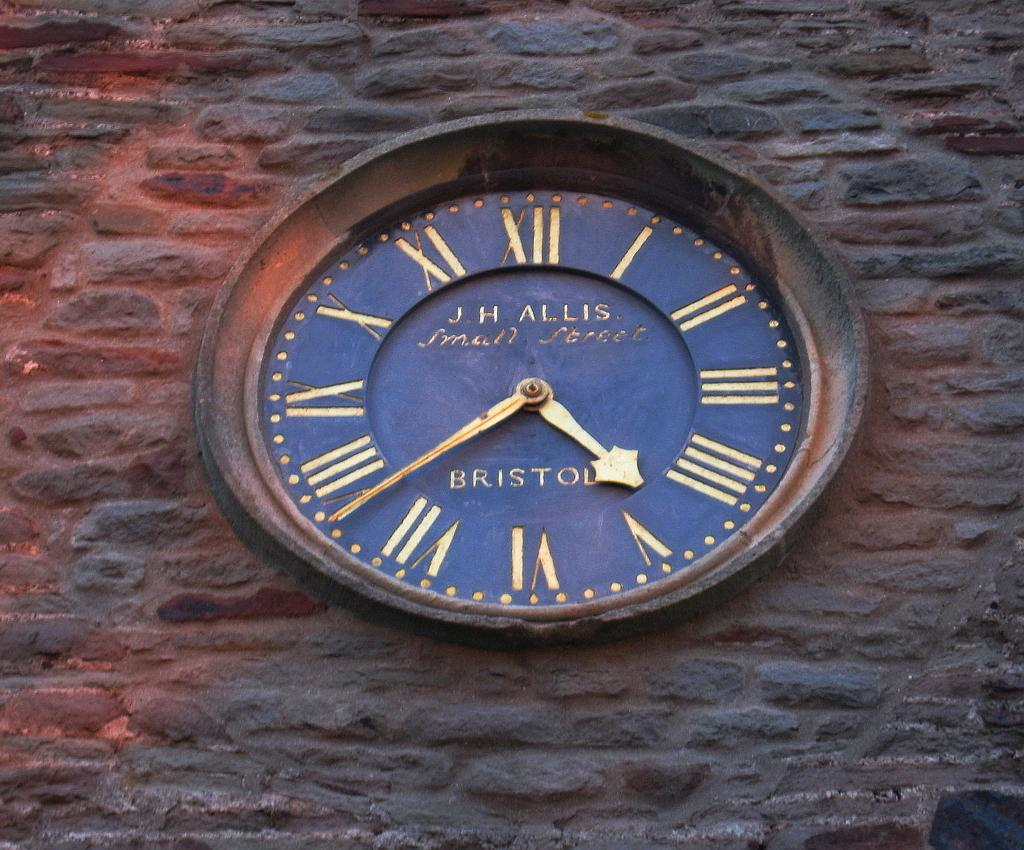Provide a one-sentence caption for the provided image. An antique J.H. Allis clock with a rustic border and a navy blue background is depicted. 